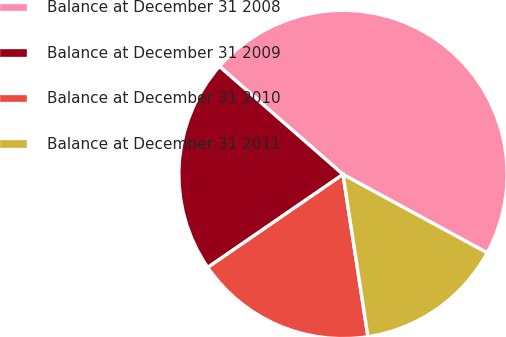Convert chart. <chart><loc_0><loc_0><loc_500><loc_500><pie_chart><fcel>Balance at December 31 2008<fcel>Balance at December 31 2009<fcel>Balance at December 31 2010<fcel>Balance at December 31 2011<nl><fcel>46.49%<fcel>21.02%<fcel>17.84%<fcel>14.65%<nl></chart> 